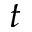Convert formula to latex. <formula><loc_0><loc_0><loc_500><loc_500>t</formula> 